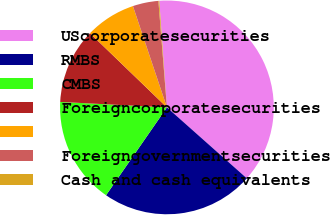<chart> <loc_0><loc_0><loc_500><loc_500><pie_chart><fcel>UScorporatesecurities<fcel>RMBS<fcel>CMBS<fcel>Foreigncorporatesecurities<fcel>Unnamed: 4<fcel>Foreigngovernmentsecurities<fcel>Cash and cash equivalents<nl><fcel>37.7%<fcel>23.09%<fcel>16.17%<fcel>11.4%<fcel>7.64%<fcel>3.88%<fcel>0.13%<nl></chart> 